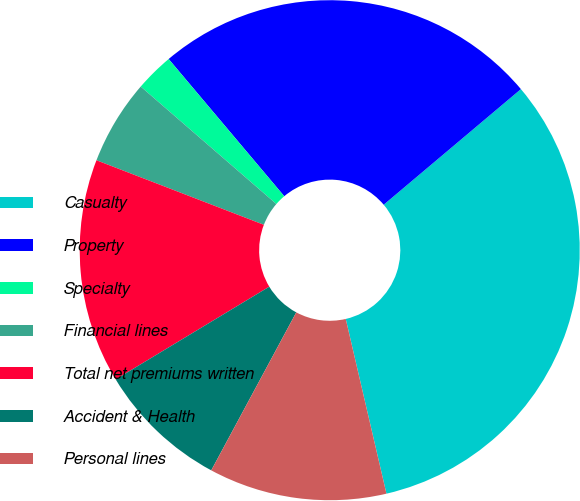Convert chart to OTSL. <chart><loc_0><loc_0><loc_500><loc_500><pie_chart><fcel>Casualty<fcel>Property<fcel>Specialty<fcel>Financial lines<fcel>Total net premiums written<fcel>Accident & Health<fcel>Personal lines<nl><fcel>32.5%<fcel>25.0%<fcel>2.5%<fcel>5.5%<fcel>14.5%<fcel>8.5%<fcel>11.5%<nl></chart> 